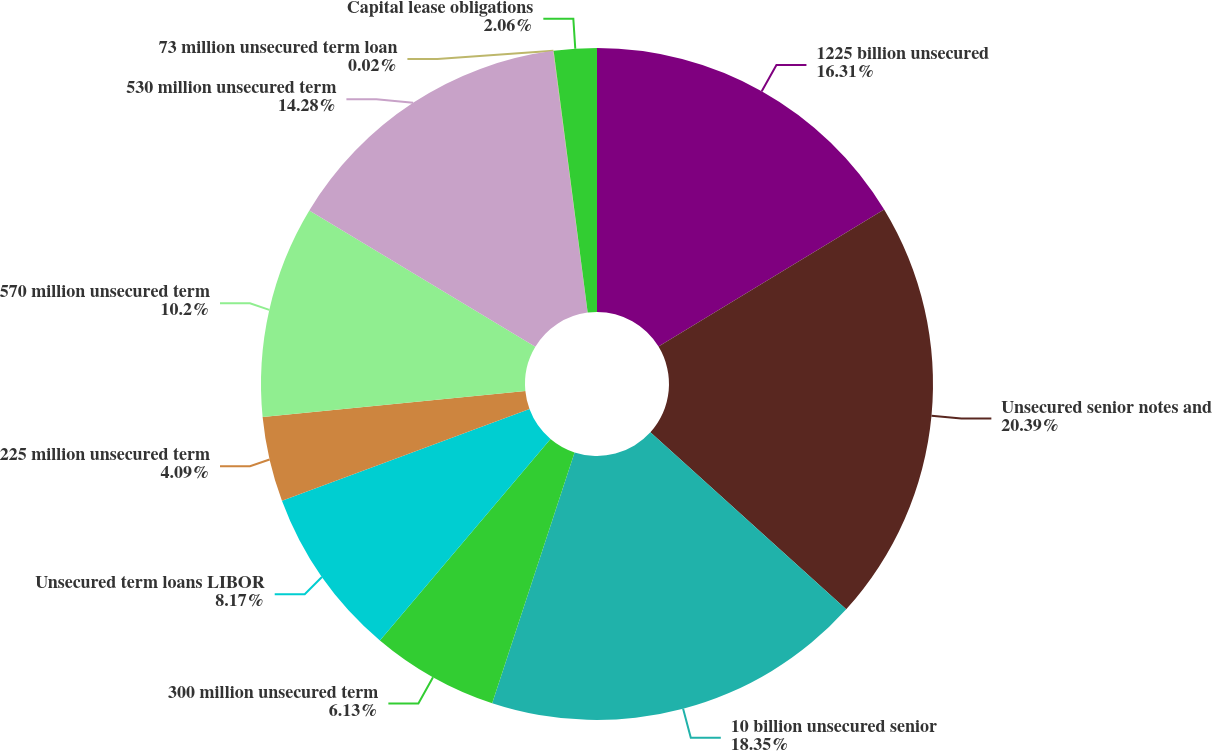Convert chart to OTSL. <chart><loc_0><loc_0><loc_500><loc_500><pie_chart><fcel>1225 billion unsecured<fcel>Unsecured senior notes and<fcel>10 billion unsecured senior<fcel>300 million unsecured term<fcel>Unsecured term loans LIBOR<fcel>225 million unsecured term<fcel>570 million unsecured term<fcel>530 million unsecured term<fcel>73 million unsecured term loan<fcel>Capital lease obligations<nl><fcel>16.31%<fcel>20.39%<fcel>18.35%<fcel>6.13%<fcel>8.17%<fcel>4.09%<fcel>10.2%<fcel>14.28%<fcel>0.02%<fcel>2.06%<nl></chart> 